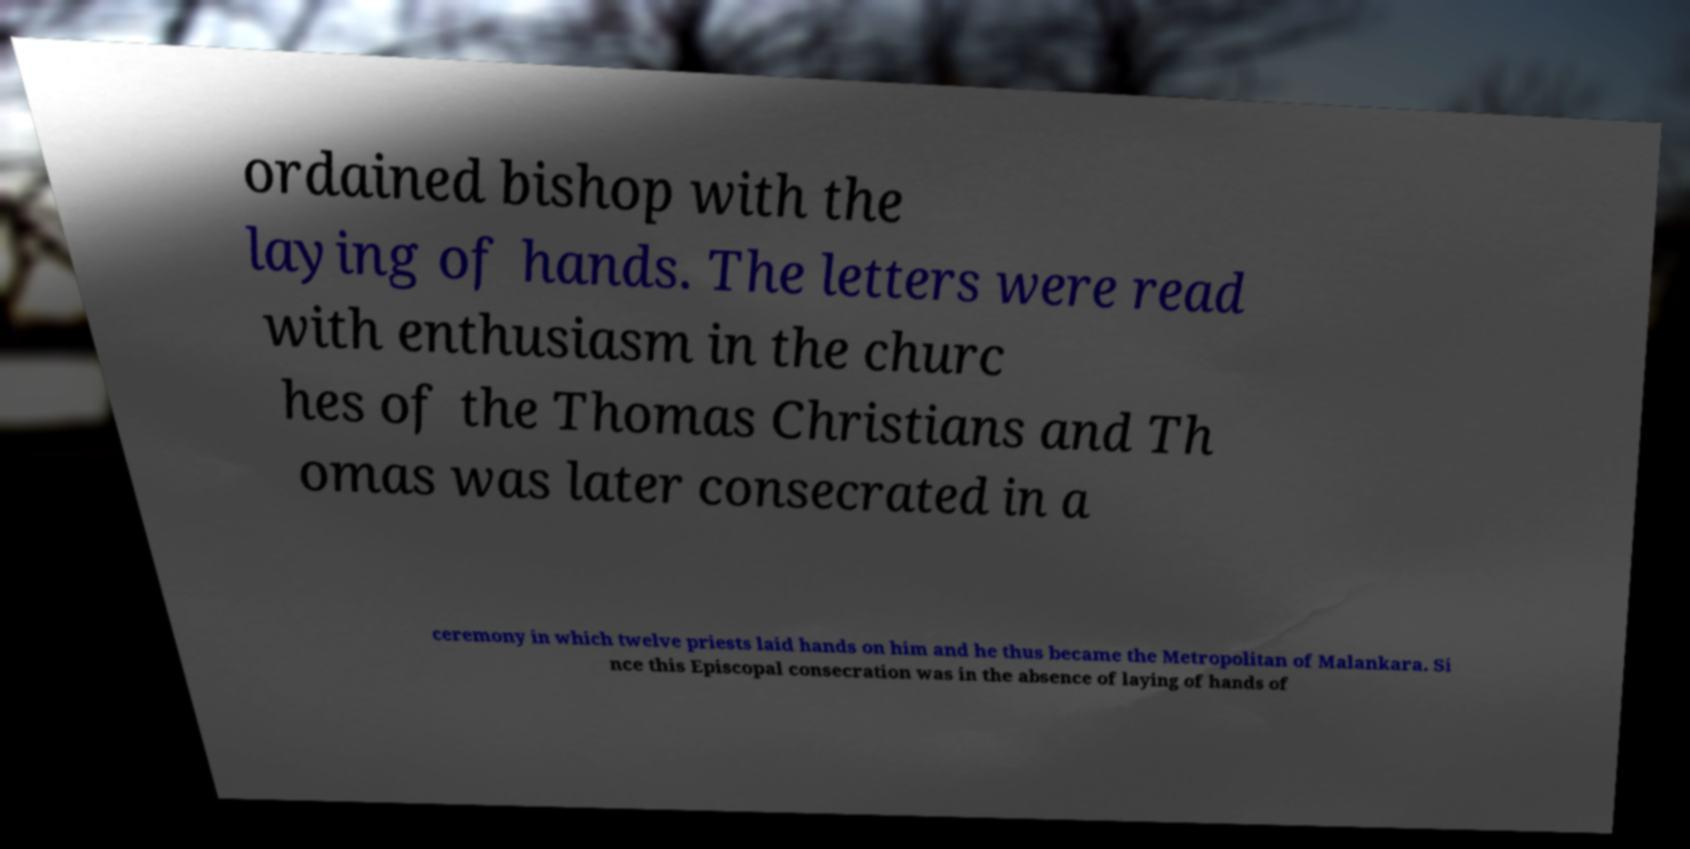What messages or text are displayed in this image? I need them in a readable, typed format. ordained bishop with the laying of hands. The letters were read with enthusiasm in the churc hes of the Thomas Christians and Th omas was later consecrated in a ceremony in which twelve priests laid hands on him and he thus became the Metropolitan of Malankara. Si nce this Episcopal consecration was in the absence of laying of hands of 